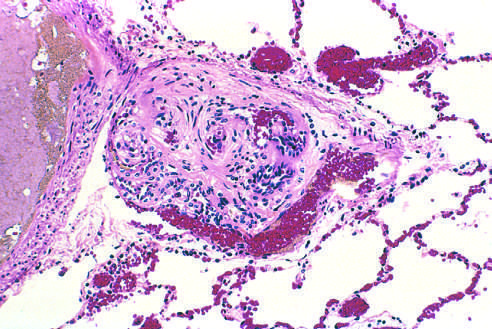s plexiform lesion characteristic of advanced pulmonary hypertension seen in small arteries?
Answer the question using a single word or phrase. Yes 